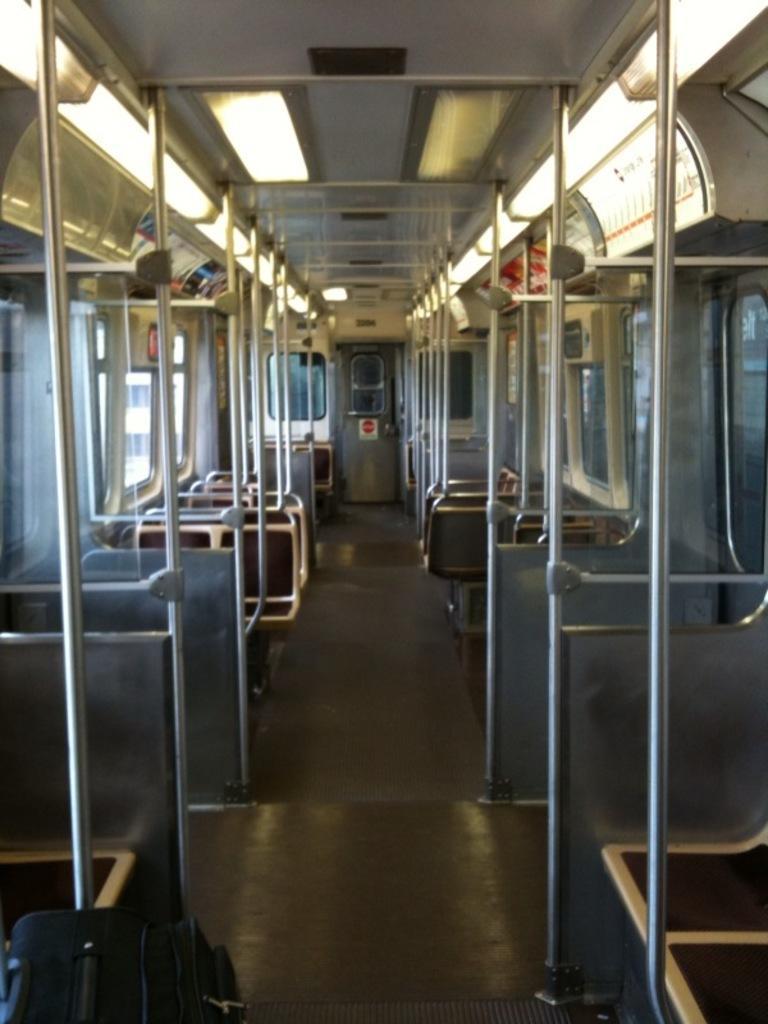Can you describe this image briefly? In this image we can see many seats on the left and right side. There are many windows, and in the background we can see the door. 